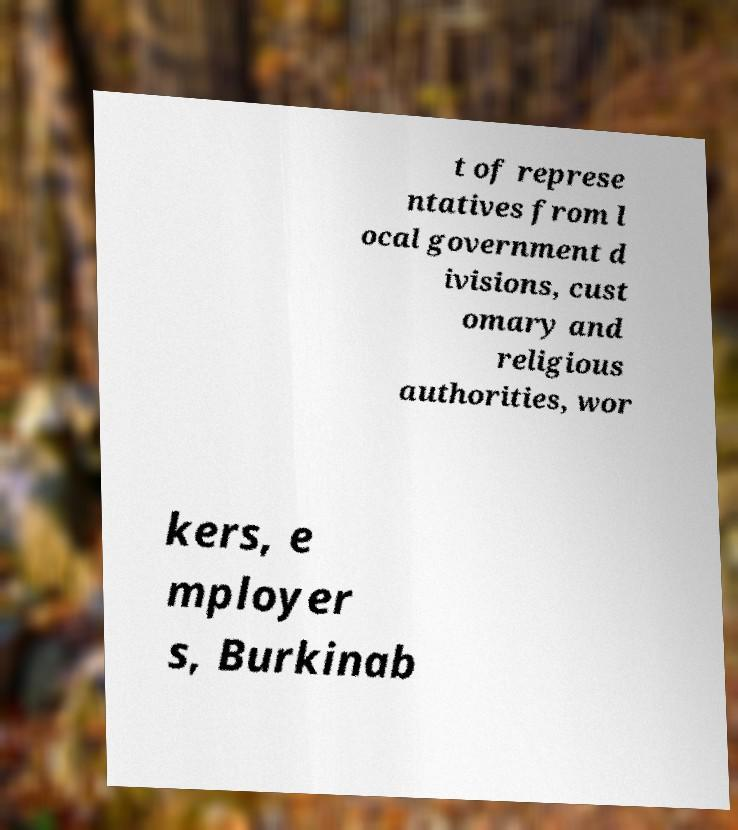I need the written content from this picture converted into text. Can you do that? t of represe ntatives from l ocal government d ivisions, cust omary and religious authorities, wor kers, e mployer s, Burkinab 